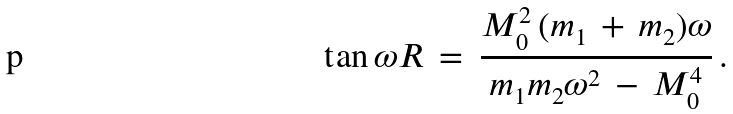<formula> <loc_0><loc_0><loc_500><loc_500>\tan \omega R \, = \, \frac { M _ { 0 } ^ { 2 } \, ( m _ { 1 } \, + \, m _ { 2 } ) \omega } { m _ { 1 } m _ { 2 } \omega ^ { 2 } \, - \, M _ { 0 } ^ { 4 } } \, { . }</formula> 